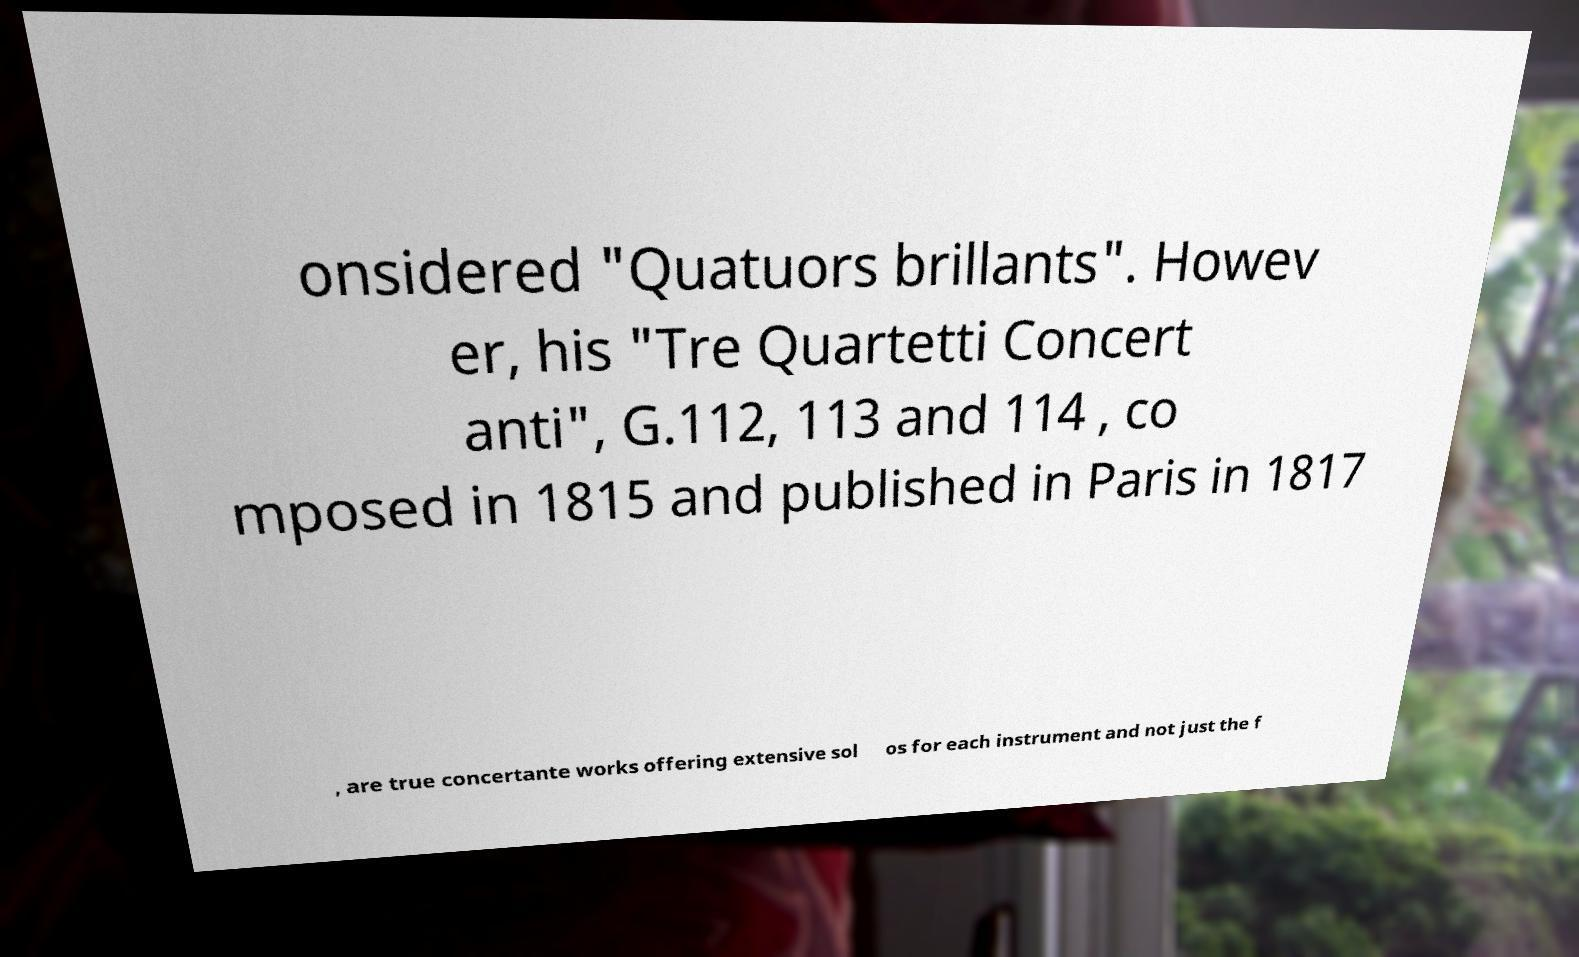Can you read and provide the text displayed in the image?This photo seems to have some interesting text. Can you extract and type it out for me? onsidered "Quatuors brillants". Howev er, his "Tre Quartetti Concert anti", G.112, 113 and 114 , co mposed in 1815 and published in Paris in 1817 , are true concertante works offering extensive sol os for each instrument and not just the f 